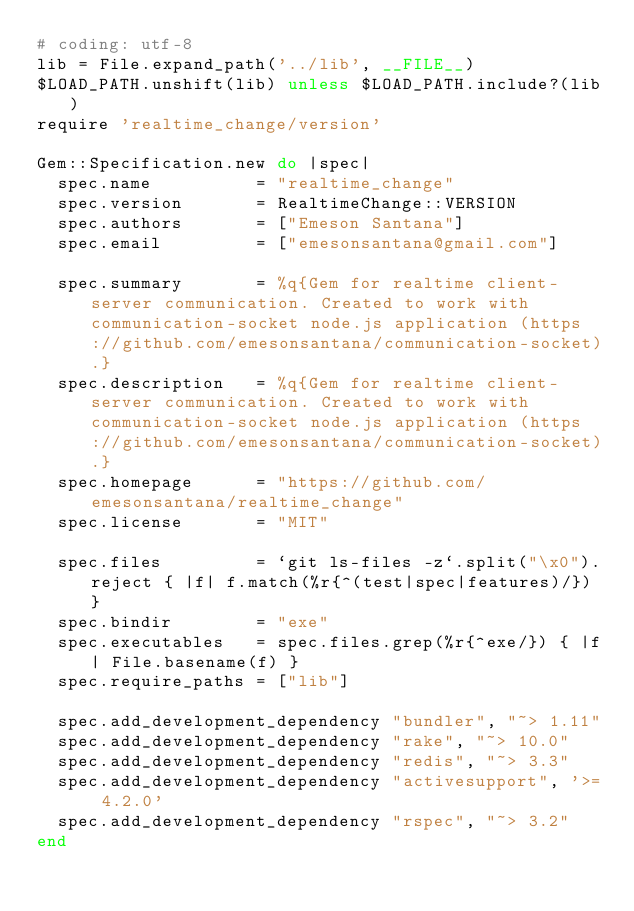<code> <loc_0><loc_0><loc_500><loc_500><_Ruby_># coding: utf-8
lib = File.expand_path('../lib', __FILE__)
$LOAD_PATH.unshift(lib) unless $LOAD_PATH.include?(lib)
require 'realtime_change/version'

Gem::Specification.new do |spec|
  spec.name          = "realtime_change"
  spec.version       = RealtimeChange::VERSION
  spec.authors       = ["Emeson Santana"]
  spec.email         = ["emesonsantana@gmail.com"]

  spec.summary       = %q{Gem for realtime client-server communication. Created to work with communication-socket node.js application (https://github.com/emesonsantana/communication-socket).}
  spec.description   = %q{Gem for realtime client-server communication. Created to work with communication-socket node.js application (https://github.com/emesonsantana/communication-socket).}
  spec.homepage      = "https://github.com/emesonsantana/realtime_change"
  spec.license       = "MIT"

  spec.files         = `git ls-files -z`.split("\x0").reject { |f| f.match(%r{^(test|spec|features)/}) }
  spec.bindir        = "exe"
  spec.executables   = spec.files.grep(%r{^exe/}) { |f| File.basename(f) }
  spec.require_paths = ["lib"]

  spec.add_development_dependency "bundler", "~> 1.11"
  spec.add_development_dependency "rake", "~> 10.0"
  spec.add_development_dependency "redis", "~> 3.3"
  spec.add_development_dependency "activesupport", '>= 4.2.0'
  spec.add_development_dependency "rspec", "~> 3.2"
end
</code> 